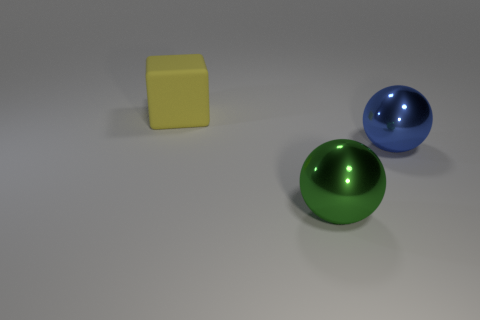What is the material of the object that is to the right of the metallic thing to the left of the blue shiny thing?
Make the answer very short. Metal. What number of metallic spheres are the same color as the large rubber block?
Keep it short and to the point. 0. What size is the green sphere that is made of the same material as the big blue sphere?
Ensure brevity in your answer.  Large. The object to the left of the big green metallic ball has what shape?
Your answer should be very brief. Cube. What size is the blue thing that is the same shape as the big green thing?
Make the answer very short. Large. There is a metallic thing left of the big sphere behind the large green metallic object; how many yellow matte things are on the right side of it?
Your answer should be compact. 0. Is the number of big blue spheres behind the big rubber thing the same as the number of big yellow things?
Your answer should be very brief. No. What number of cylinders are blue objects or big rubber objects?
Make the answer very short. 0. Is the number of large things that are behind the big yellow block the same as the number of big cubes in front of the green sphere?
Make the answer very short. Yes. The block is what color?
Make the answer very short. Yellow. 